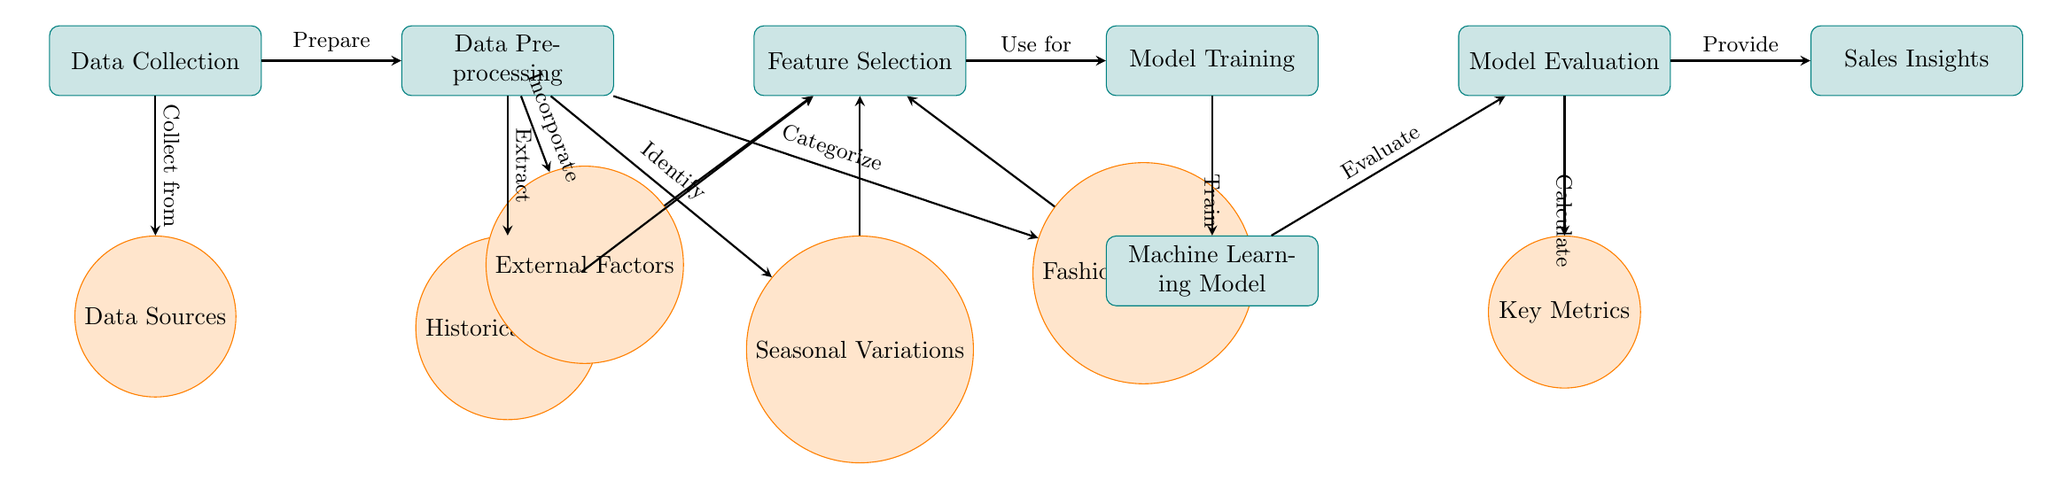What is the starting point of the diagram? The diagram begins with the "Data Collection" process, which is the first node labeled as such.
Answer: Data Collection How many data sources are indicated in the diagram? There is one node labeled "Data Sources," which represents the data sources involved in the process.
Answer: One What is the process that follows data preprocessing? After "Data Preprocessing," the next process is "Feature Selection." This is shown directly to the right of preprocessing.
Answer: Feature Selection List the types of data processed before model training. The data processed before "Model Training" includes "Historical Sales," "Seasonal Variations," "Fashion Categories," and "External Factors," which are all extracted from the "Data Preprocessing" node.
Answer: Historical Sales, Seasonal Variations, Fashion Categories, External Factors What process comes after model evaluation? Following "Model Evaluation," the diagram indicates two outputs: "Key Metrics" and "Sales Insights." These show the results from evaluation.
Answer: Key Metrics, Sales Insights Which node is the output of the "Model Training"? The output from "Model Training" directly leads to the node labeled "Machine Learning Model." This is essential in the training step of the flow.
Answer: Machine Learning Model What does the arrow labeled "Incorporate" indicate? The "Incorporate" arrow shows the connection from "External Factors" to "Feature Selection," indicating that external factors are taken into account during feature selection.
Answer: Incorporate What is the relationship between "Model Training" and "Machine Learning Model"? "Model Training" leads to "Machine Learning Model," where the training process occurs to create the ML model itself, showing progression from training to development of the model.
Answer: Train What kind of insights are provided after evaluation? The insights provided after "Model Evaluation" include "Sales Insights," which convey the key findings that stem from the evaluation process.
Answer: Sales Insights 